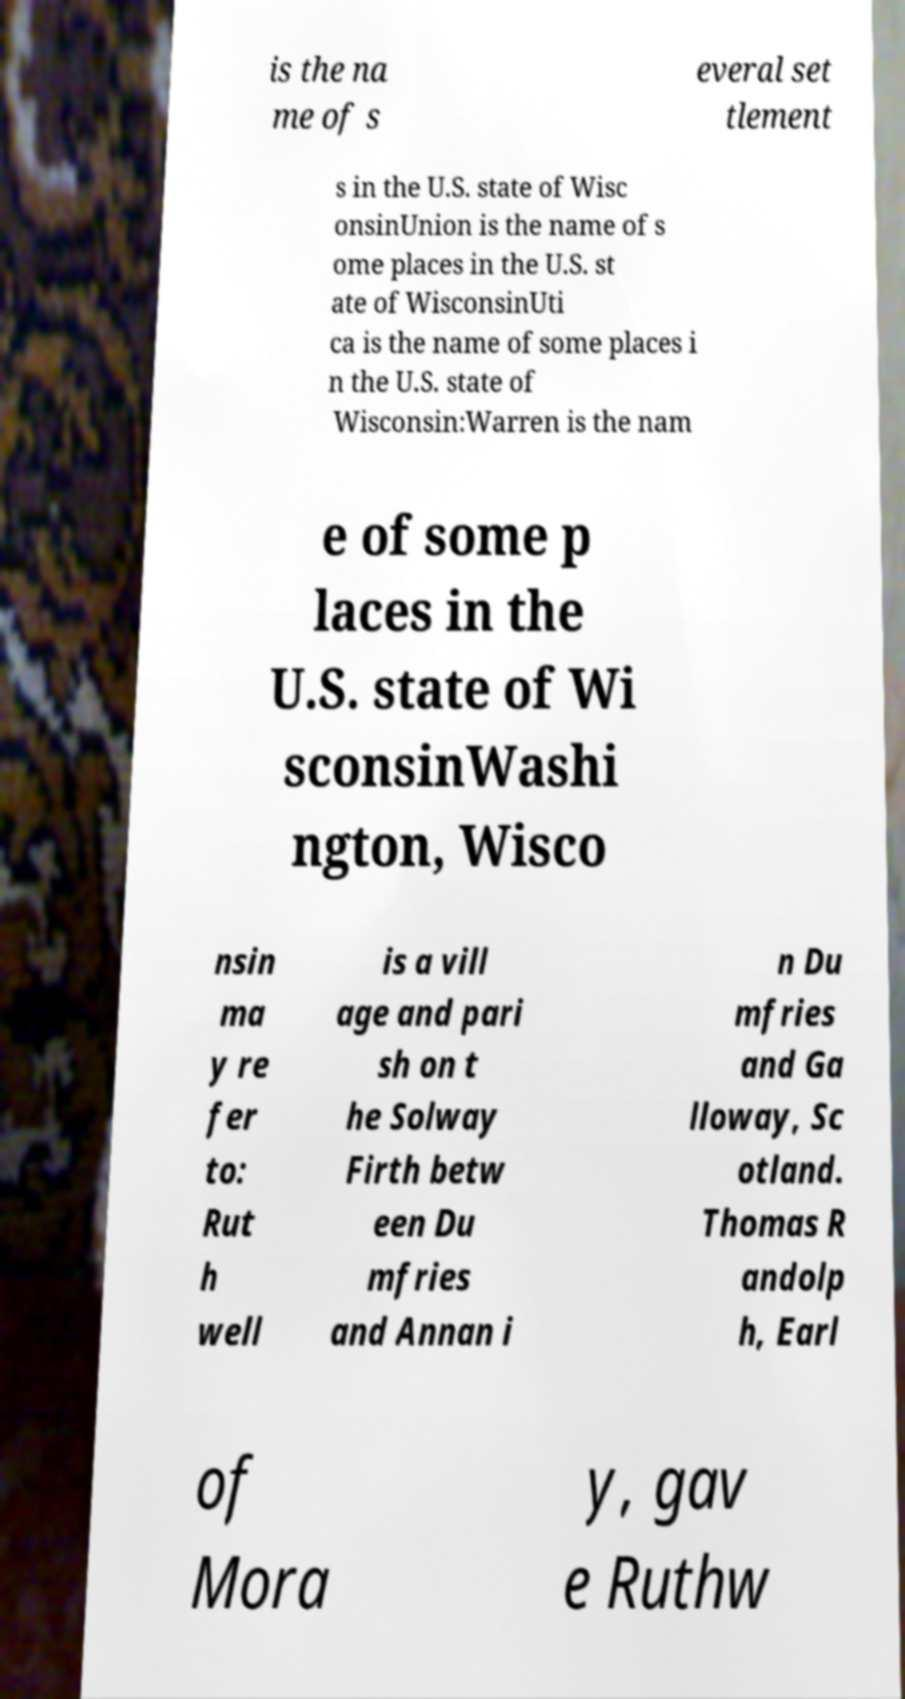I need the written content from this picture converted into text. Can you do that? is the na me of s everal set tlement s in the U.S. state of Wisc onsinUnion is the name of s ome places in the U.S. st ate of WisconsinUti ca is the name of some places i n the U.S. state of Wisconsin:Warren is the nam e of some p laces in the U.S. state of Wi sconsinWashi ngton, Wisco nsin ma y re fer to: Rut h well is a vill age and pari sh on t he Solway Firth betw een Du mfries and Annan i n Du mfries and Ga lloway, Sc otland. Thomas R andolp h, Earl of Mora y, gav e Ruthw 